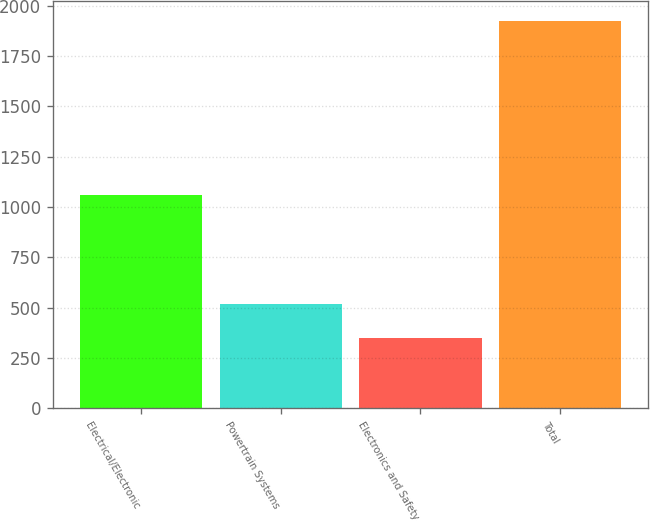Convert chart to OTSL. <chart><loc_0><loc_0><loc_500><loc_500><bar_chart><fcel>Electrical/Electronic<fcel>Powertrain Systems<fcel>Electronics and Safety<fcel>Total<nl><fcel>1060<fcel>518<fcel>347<fcel>1925<nl></chart> 